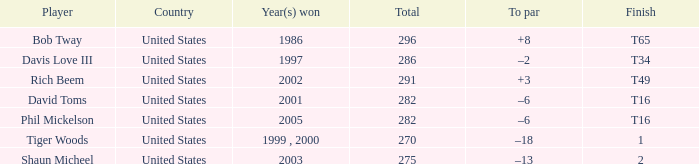In which year(s) did the person with a total greater than 286 win? 2002, 1986. 